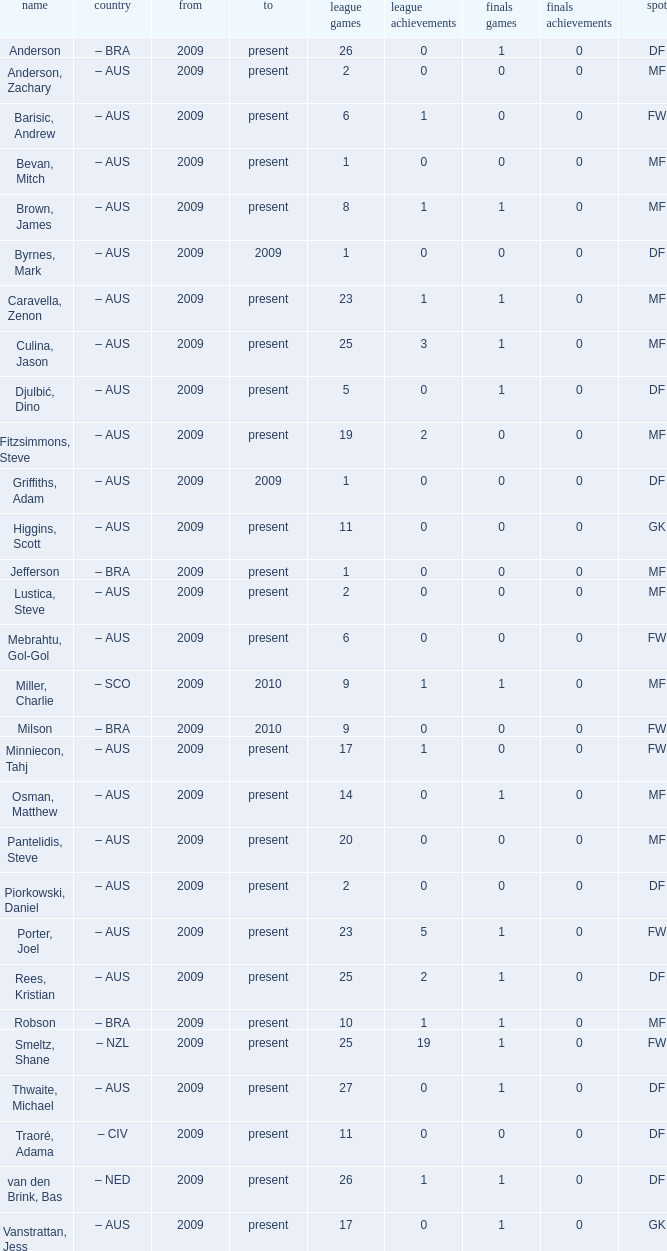Name the to for 19 league apps Present. 